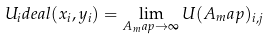<formula> <loc_0><loc_0><loc_500><loc_500>U _ { i } d e a l ( x _ { i } , y _ { i } ) = \lim _ { A _ { m } a p \rightarrow \infty } U ( A _ { m } a p ) _ { i , j }</formula> 